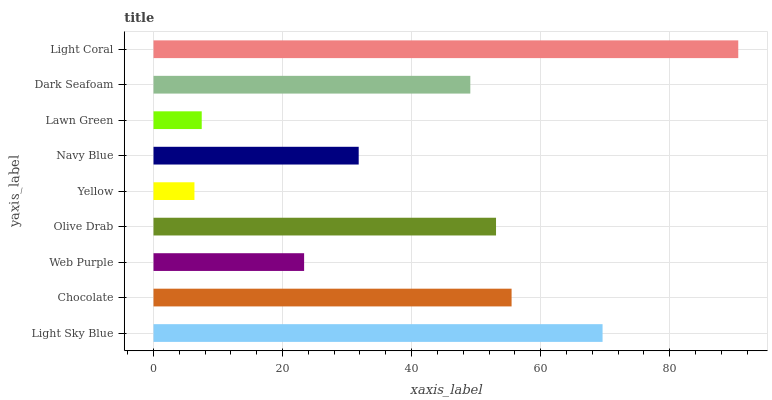Is Yellow the minimum?
Answer yes or no. Yes. Is Light Coral the maximum?
Answer yes or no. Yes. Is Chocolate the minimum?
Answer yes or no. No. Is Chocolate the maximum?
Answer yes or no. No. Is Light Sky Blue greater than Chocolate?
Answer yes or no. Yes. Is Chocolate less than Light Sky Blue?
Answer yes or no. Yes. Is Chocolate greater than Light Sky Blue?
Answer yes or no. No. Is Light Sky Blue less than Chocolate?
Answer yes or no. No. Is Dark Seafoam the high median?
Answer yes or no. Yes. Is Dark Seafoam the low median?
Answer yes or no. Yes. Is Lawn Green the high median?
Answer yes or no. No. Is Lawn Green the low median?
Answer yes or no. No. 